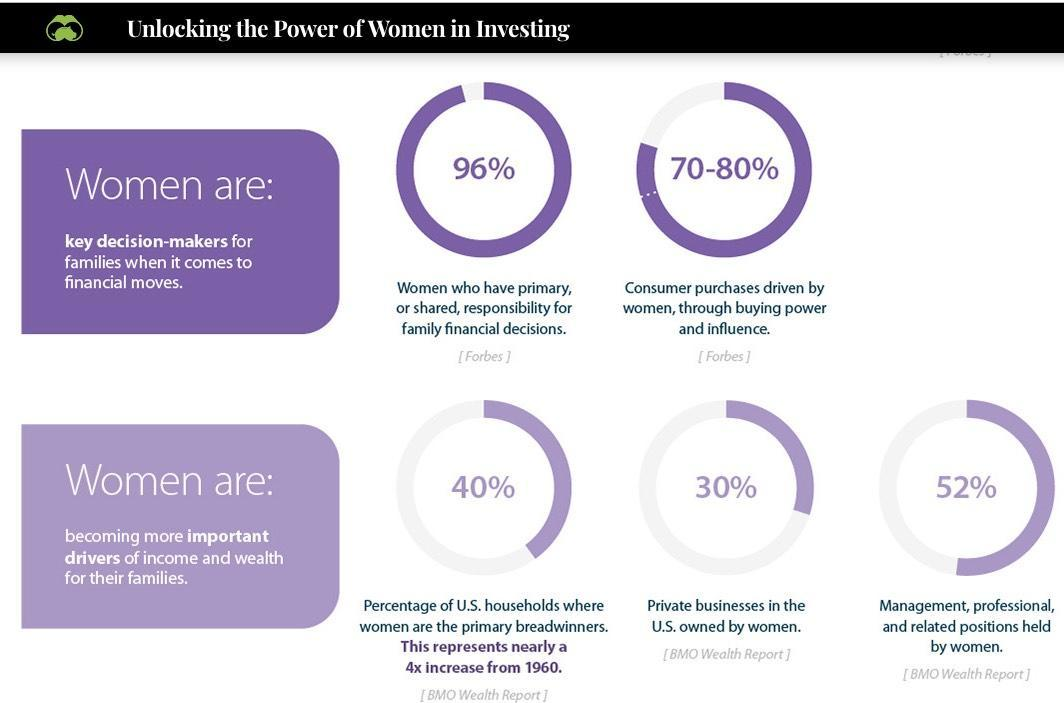What percentage of consumer purchases are driven by women through buying power & influence?
Answer the question with a short phrase. 70-80% What percentage of private businesses in the U.S are owned by women? 30% What percentage of management, professional & related positions are held by women? 52% 